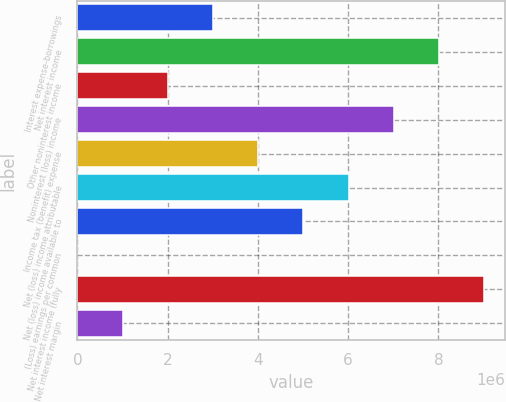Convert chart to OTSL. <chart><loc_0><loc_0><loc_500><loc_500><bar_chart><fcel>Interest expense-borrowings<fcel>Net interest income<fcel>Other noninterest income<fcel>Noninterest (loss) income<fcel>Income tax (benefit) expense<fcel>Net (loss) income attributable<fcel>Net (loss) income available to<fcel>(Loss) earnings per common<fcel>Net interest income (fully<fcel>Net interest margin<nl><fcel>3.00627e+06<fcel>8.01671e+06<fcel>2.00418e+06<fcel>7.01463e+06<fcel>4.00836e+06<fcel>6.01254e+06<fcel>5.01045e+06<fcel>2.29<fcel>9.0188e+06<fcel>1.00209e+06<nl></chart> 